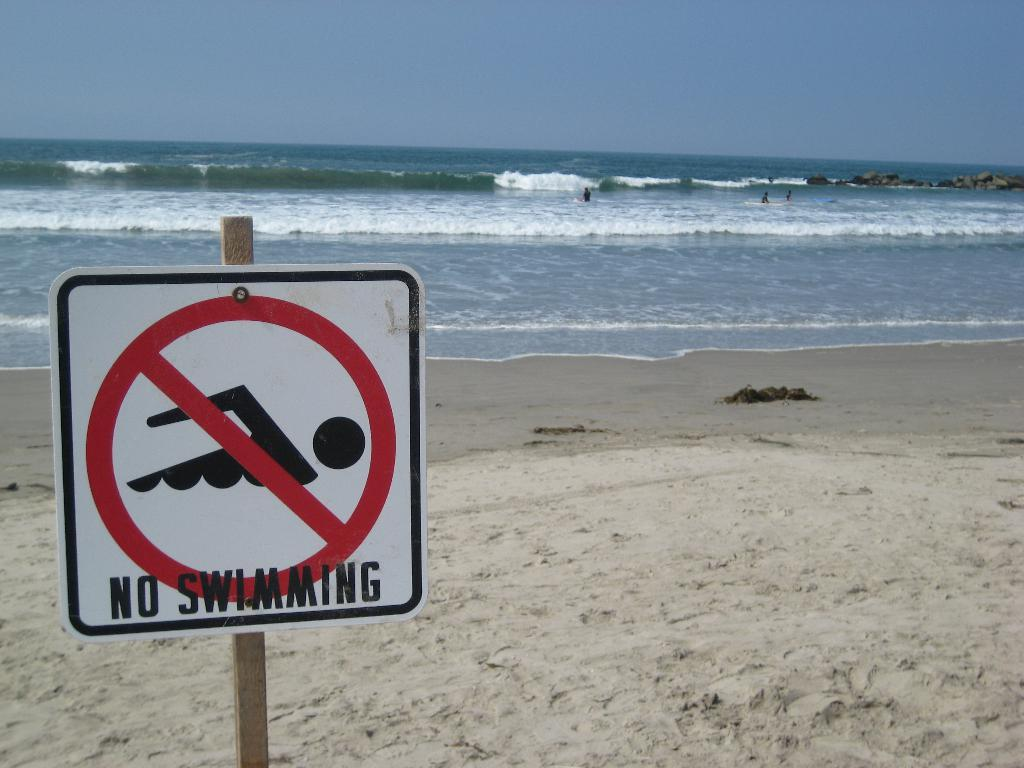<image>
Give a short and clear explanation of the subsequent image. A sign on the beach shows that swimming is not allowed. 